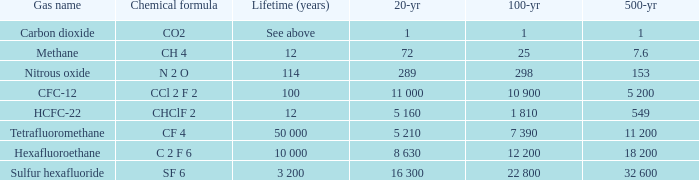What is the 20-year timeframe for nitrous oxide? 289.0. 